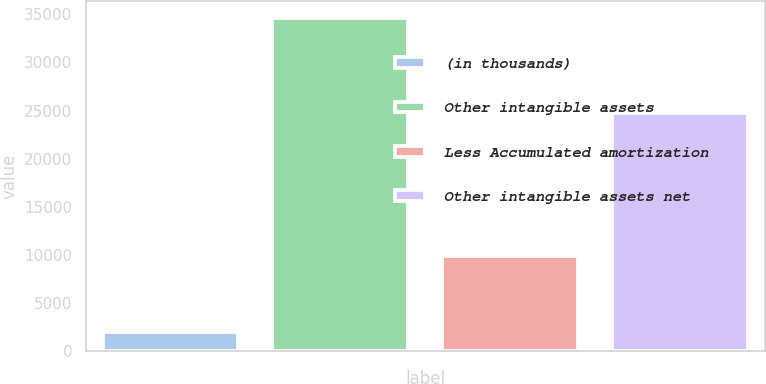Convert chart. <chart><loc_0><loc_0><loc_500><loc_500><bar_chart><fcel>(in thousands)<fcel>Other intangible assets<fcel>Less Accumulated amortization<fcel>Other intangible assets net<nl><fcel>2009<fcel>34655<fcel>9870<fcel>24785<nl></chart> 